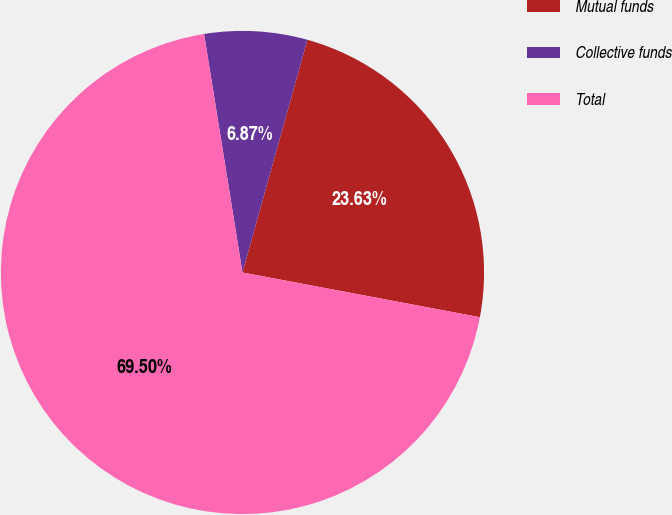Convert chart to OTSL. <chart><loc_0><loc_0><loc_500><loc_500><pie_chart><fcel>Mutual funds<fcel>Collective funds<fcel>Total<nl><fcel>23.63%<fcel>6.87%<fcel>69.49%<nl></chart> 